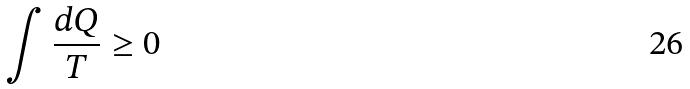Convert formula to latex. <formula><loc_0><loc_0><loc_500><loc_500>\int \frac { d Q } { T } \geq 0</formula> 